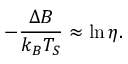Convert formula to latex. <formula><loc_0><loc_0><loc_500><loc_500>- \frac { \Delta B } { k _ { B } T _ { S } } \approx \ln \eta .</formula> 